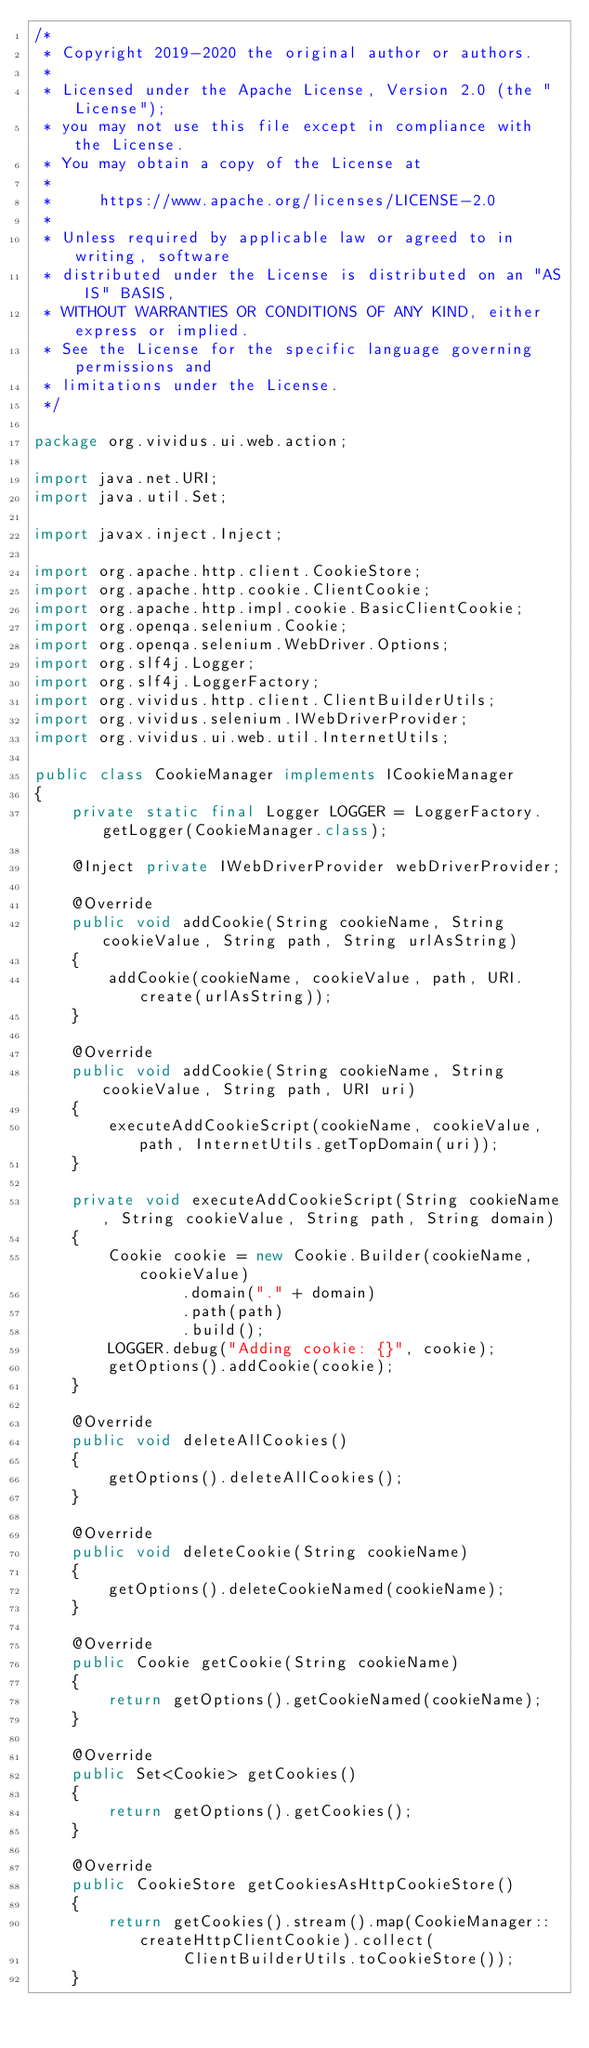Convert code to text. <code><loc_0><loc_0><loc_500><loc_500><_Java_>/*
 * Copyright 2019-2020 the original author or authors.
 *
 * Licensed under the Apache License, Version 2.0 (the "License");
 * you may not use this file except in compliance with the License.
 * You may obtain a copy of the License at
 *
 *     https://www.apache.org/licenses/LICENSE-2.0
 *
 * Unless required by applicable law or agreed to in writing, software
 * distributed under the License is distributed on an "AS IS" BASIS,
 * WITHOUT WARRANTIES OR CONDITIONS OF ANY KIND, either express or implied.
 * See the License for the specific language governing permissions and
 * limitations under the License.
 */

package org.vividus.ui.web.action;

import java.net.URI;
import java.util.Set;

import javax.inject.Inject;

import org.apache.http.client.CookieStore;
import org.apache.http.cookie.ClientCookie;
import org.apache.http.impl.cookie.BasicClientCookie;
import org.openqa.selenium.Cookie;
import org.openqa.selenium.WebDriver.Options;
import org.slf4j.Logger;
import org.slf4j.LoggerFactory;
import org.vividus.http.client.ClientBuilderUtils;
import org.vividus.selenium.IWebDriverProvider;
import org.vividus.ui.web.util.InternetUtils;

public class CookieManager implements ICookieManager
{
    private static final Logger LOGGER = LoggerFactory.getLogger(CookieManager.class);

    @Inject private IWebDriverProvider webDriverProvider;

    @Override
    public void addCookie(String cookieName, String cookieValue, String path, String urlAsString)
    {
        addCookie(cookieName, cookieValue, path, URI.create(urlAsString));
    }

    @Override
    public void addCookie(String cookieName, String cookieValue, String path, URI uri)
    {
        executeAddCookieScript(cookieName, cookieValue, path, InternetUtils.getTopDomain(uri));
    }

    private void executeAddCookieScript(String cookieName, String cookieValue, String path, String domain)
    {
        Cookie cookie = new Cookie.Builder(cookieName, cookieValue)
                .domain("." + domain)
                .path(path)
                .build();
        LOGGER.debug("Adding cookie: {}", cookie);
        getOptions().addCookie(cookie);
    }

    @Override
    public void deleteAllCookies()
    {
        getOptions().deleteAllCookies();
    }

    @Override
    public void deleteCookie(String cookieName)
    {
        getOptions().deleteCookieNamed(cookieName);
    }

    @Override
    public Cookie getCookie(String cookieName)
    {
        return getOptions().getCookieNamed(cookieName);
    }

    @Override
    public Set<Cookie> getCookies()
    {
        return getOptions().getCookies();
    }

    @Override
    public CookieStore getCookiesAsHttpCookieStore()
    {
        return getCookies().stream().map(CookieManager::createHttpClientCookie).collect(
                ClientBuilderUtils.toCookieStore());
    }
</code> 